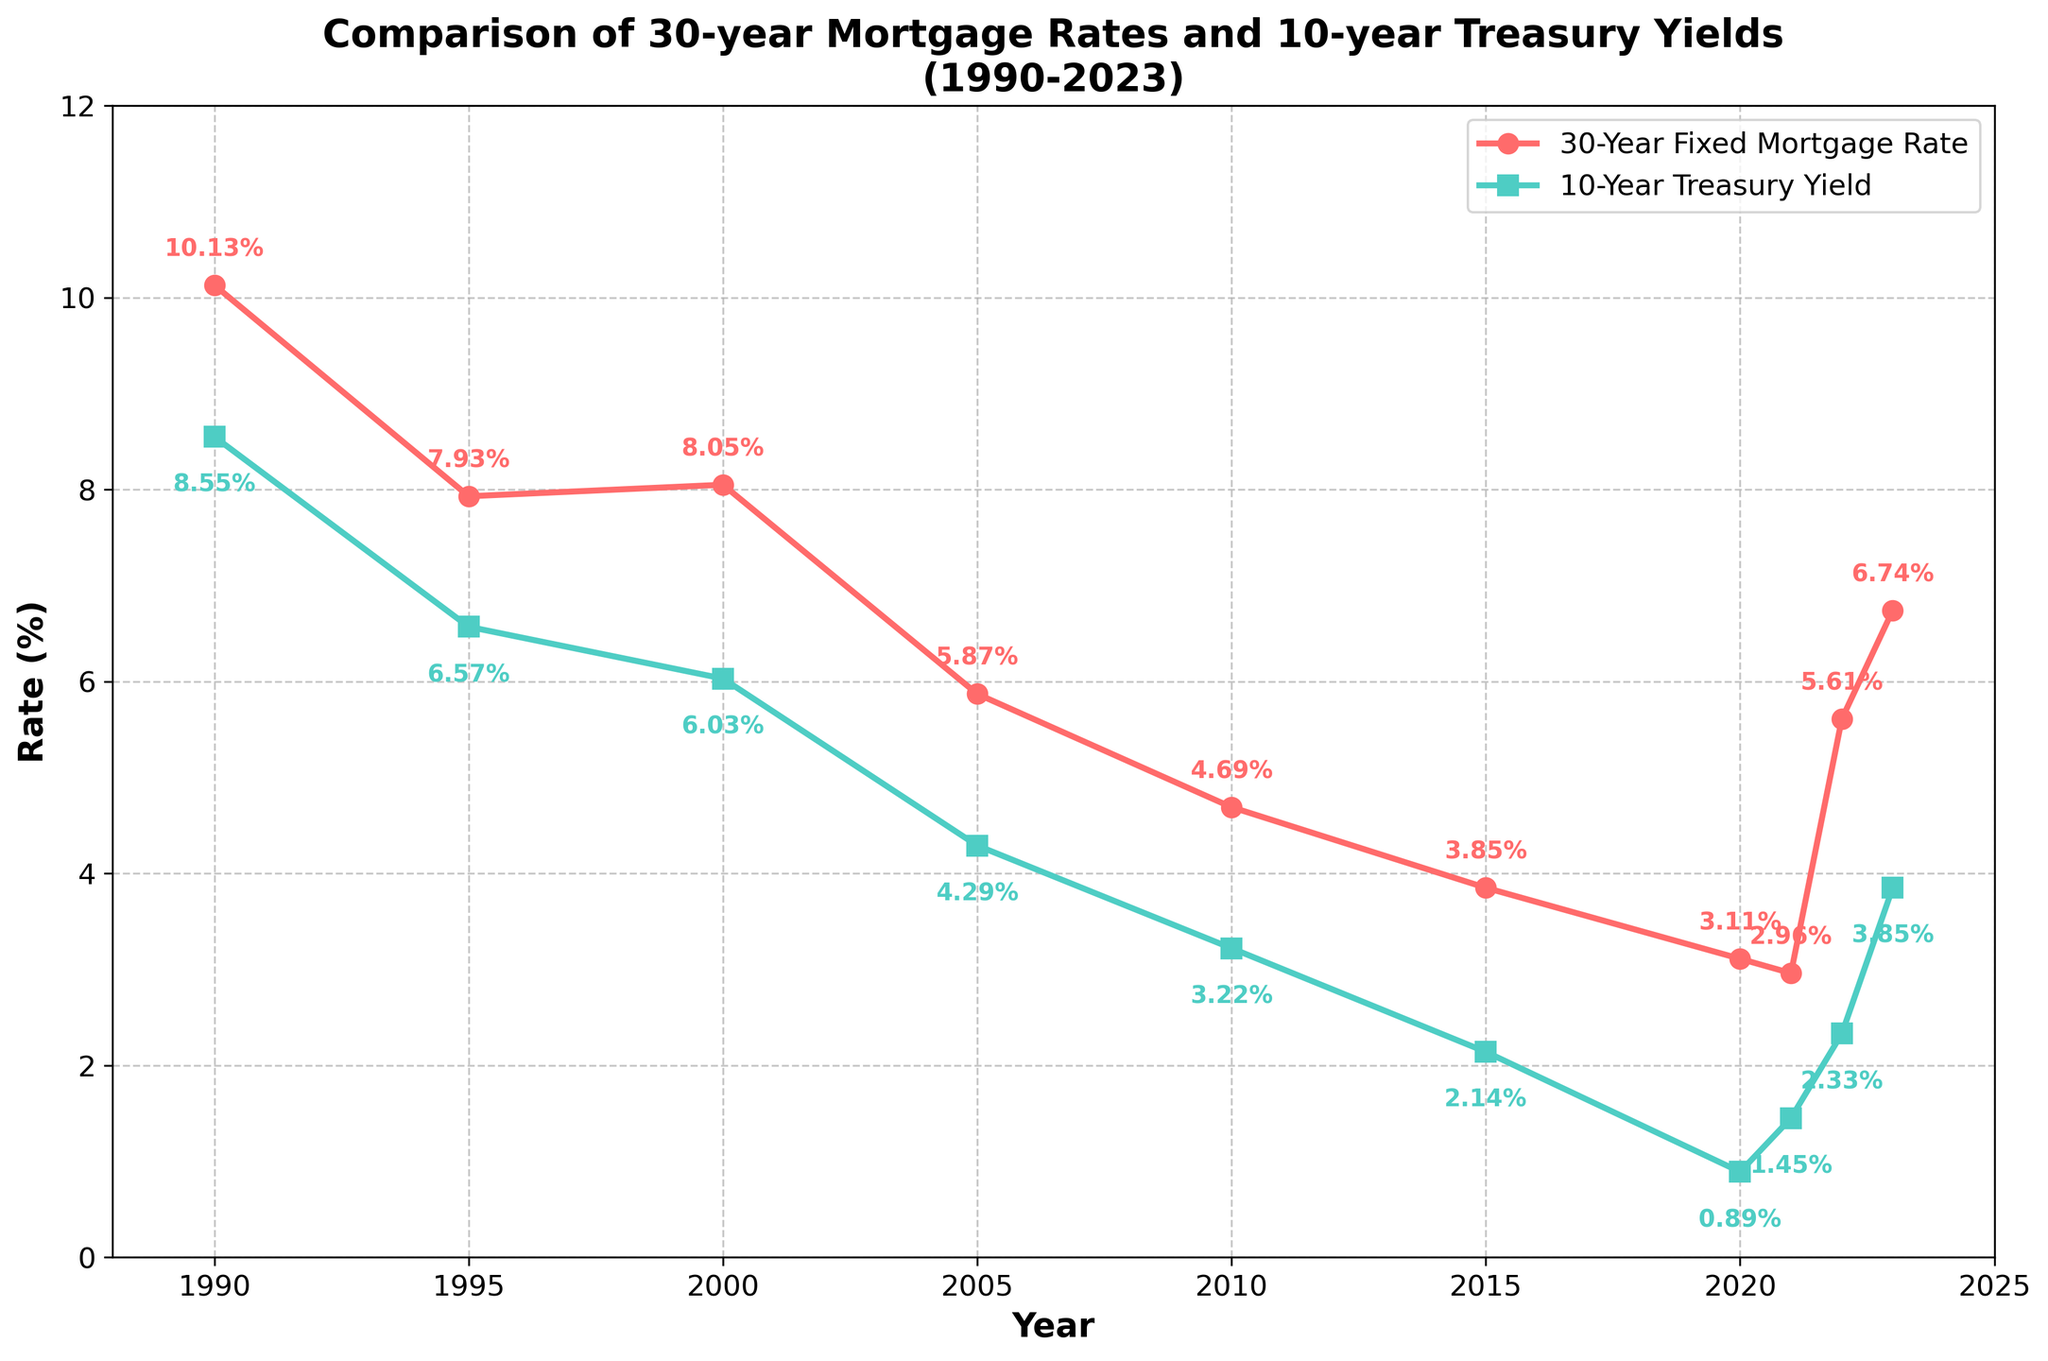What are the highest and lowest 30-year mortgage rates shown in the figure? The highest rate is in 1990 at 10.13%, and the lowest rate is in 2021 at 2.96%.
Answer: Highest: 10.13%, Lowest: 2.96% Which year shows the largest difference between the 30-year mortgage rate and the 10-year Treasury yield? In 1990, the difference is 10.13% - 8.55% = 1.58%, which is the largest over the years shown.
Answer: 1990 How did the 30-year mortgage rate change from 2020 to 2023? In 2020, the rate was 3.11%. By 2023, it increased to 6.74%. Thus, the change is 6.74% - 3.11% = 3.63%.
Answer: An increase of 3.63% Does the pattern of the 10-year Treasury yield follow the 30-year mortgage rate consistently? Both lines exhibit a general downward trend from 1990 to around 2015, with both rising again towards 2023. Although they don’t match exactly year by year, their overall trends correspond.
Answer: Generally yes In which year(s) did both the 10-year Treasury yield and the 30-year mortgage rate have their lowest values? Both had their lowest values within the same year: 2020. The 30-year mortgage rate was 3.11% and the 10-year Treasury yield was 0.89%.
Answer: 2020 What are the color representations for the 30-year mortgage rate and the 10-year Treasury yield in the figure? The 30-year mortgage rate is shown in red, while the 10-year Treasury yield is shown in green. These visual distinctions help differentiate the two lines.
Answer: Mortgage: red, Treasury: green Which year saw a larger percentage increase from the previous year in the 30-year mortgage rate: 2021 to 2022 or 2022 to 2023? From 2021 to 2022, the increase was from 2.96% to 5.61%, which is (5.61 - 2.96) / 2.96 * 100 ≈ 89.53%. From 2022 to 2023, the increase was from 5.61% to 6.74%, which is (6.74 - 5.61) / 5.61 * 100 ≈ 20.18%. The larger percentage increase was from 2021 to 2022.
Answer: 2021 to 2022 For which years do the annotated values show identical increases or decreases for both the 30-year mortgage rate and the 10-year Treasury yield? In 2021, the rates decreased almost uniformly from 2020 and increased similarly in 2023. Though not exactly identical, these years show matched directional changes.
Answer: 2021 and 2023 